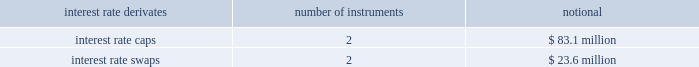Kimco realty corporation and subsidiaries notes to consolidated financial statements , continued as of december 31 , 2009 , the company had the following outstanding interest rate derivatives that were designated as cash flow hedges of interest rate risk : interest rate derivates number of instruments notional .
The fair value of these derivative financial instruments classified as asset derivatives was $ 0.4 million and $ 0 for december 31 , 2009 and 2008 , respectively .
The fair value of these derivative financial instruments classified as liability derivatives was $ ( 0.5 ) million and $ ( 0.8 ) million for december 31 , 2009 and 2008 , respectively .
Credit-risk-related contingent features the company has agreements with one of its derivative counterparties that contain a provision where if the company defaults on any of its indebtedness , including default where repayment of the indebtedness has not been accelerated by the lender , then the company could also be declared in default on its derivative obligations .
The company has an agreement with a derivative counterparty that incorporates the loan covenant provisions of the company 2019s indebtedness with a lender affiliate of the derivative counterparty .
Failure to comply with the loan covenant provisions would result in the company being in default on any derivative instrument obligations covered by the agreement .
18 .
Preferred stock , common stock and convertible unit transactions : during december 2009 , the company completed a primary public stock offering of 28750000 shares of the company 2019s common stock .
The net proceeds from this sale of common stock , totaling approximately $ 345.1 million ( after related transaction costs of $ 0.75 million ) were used to partially repay the outstanding balance under the company 2019s u.s .
Revolving credit facility .
During april 2009 , the company completed a primary public stock offering of 105225000 shares of the company 2019s common stock .
The net proceeds from this sale of common stock , totaling approximately $ 717.3 million ( after related transaction costs of $ 0.7 million ) were used to partially repay the outstanding balance under the company 2019s u.s .
Revolving credit facility and for general corporate purposes .
During september 2008 , the company completed a primary public stock offering of 11500000 shares of the company 2019s common stock .
The net proceeds from this sale of common stock , totaling approximately $ 409.4 million ( after related transaction costs of $ 0.6 million ) were used to partially repay the outstanding balance under the company 2019s u.s .
Revolving credit facility .
During october 2007 , the company issued 18400000 depositary shares ( the 201cclass g depositary shares 201d ) , after the exercise of an over-allotment option , each representing a one-hundredth fractional interest in a share of the company 2019s 7.75% ( 7.75 % ) class g cumulative redeemable preferred stock , par value $ 1.00 per share ( the 201cclass g preferred stock 201d ) .
Dividends on the class g depositary shares are cumulative and payable quarterly in arrears at the rate of 7.75% ( 7.75 % ) per annum based on the $ 25.00 per share initial offering price , or $ 1.9375 per annum .
The class g depositary shares are redeemable , in whole or part , for cash on or after october 10 , 2012 , at the option of the company , at a redemption price of $ 25.00 per depositary share , plus any accrued and unpaid dividends thereon .
The class g depositary shares are not convertible or exchangeable for any other property or securities of the company .
The class g preferred stock ( represented by the class g depositary shares outstanding ) ranks pari passu with the company 2019s class f preferred stock as to voting rights , priority for receiving dividends and liquidation preference as set forth below .
During june 2003 , the company issued 7000000 depositary shares ( the 201cclass f depositary shares 201d ) , each such class f depositary share representing a one-tenth fractional interest of a share of the company 2019s 6.65% ( 6.65 % ) class f cumulative redeemable preferred stock , par value $ 1.00 per share ( the 201cclass f preferred stock 201d ) .
Dividends on the class f depositary shares are cumulative and payable quarterly in arrears at the rate of 6.65% ( 6.65 % ) per annum based on the .
In 2009 what was the ratio of the interest rate caps to swaps? 
Computations: (83.1 / 23.6)
Answer: 3.52119. 